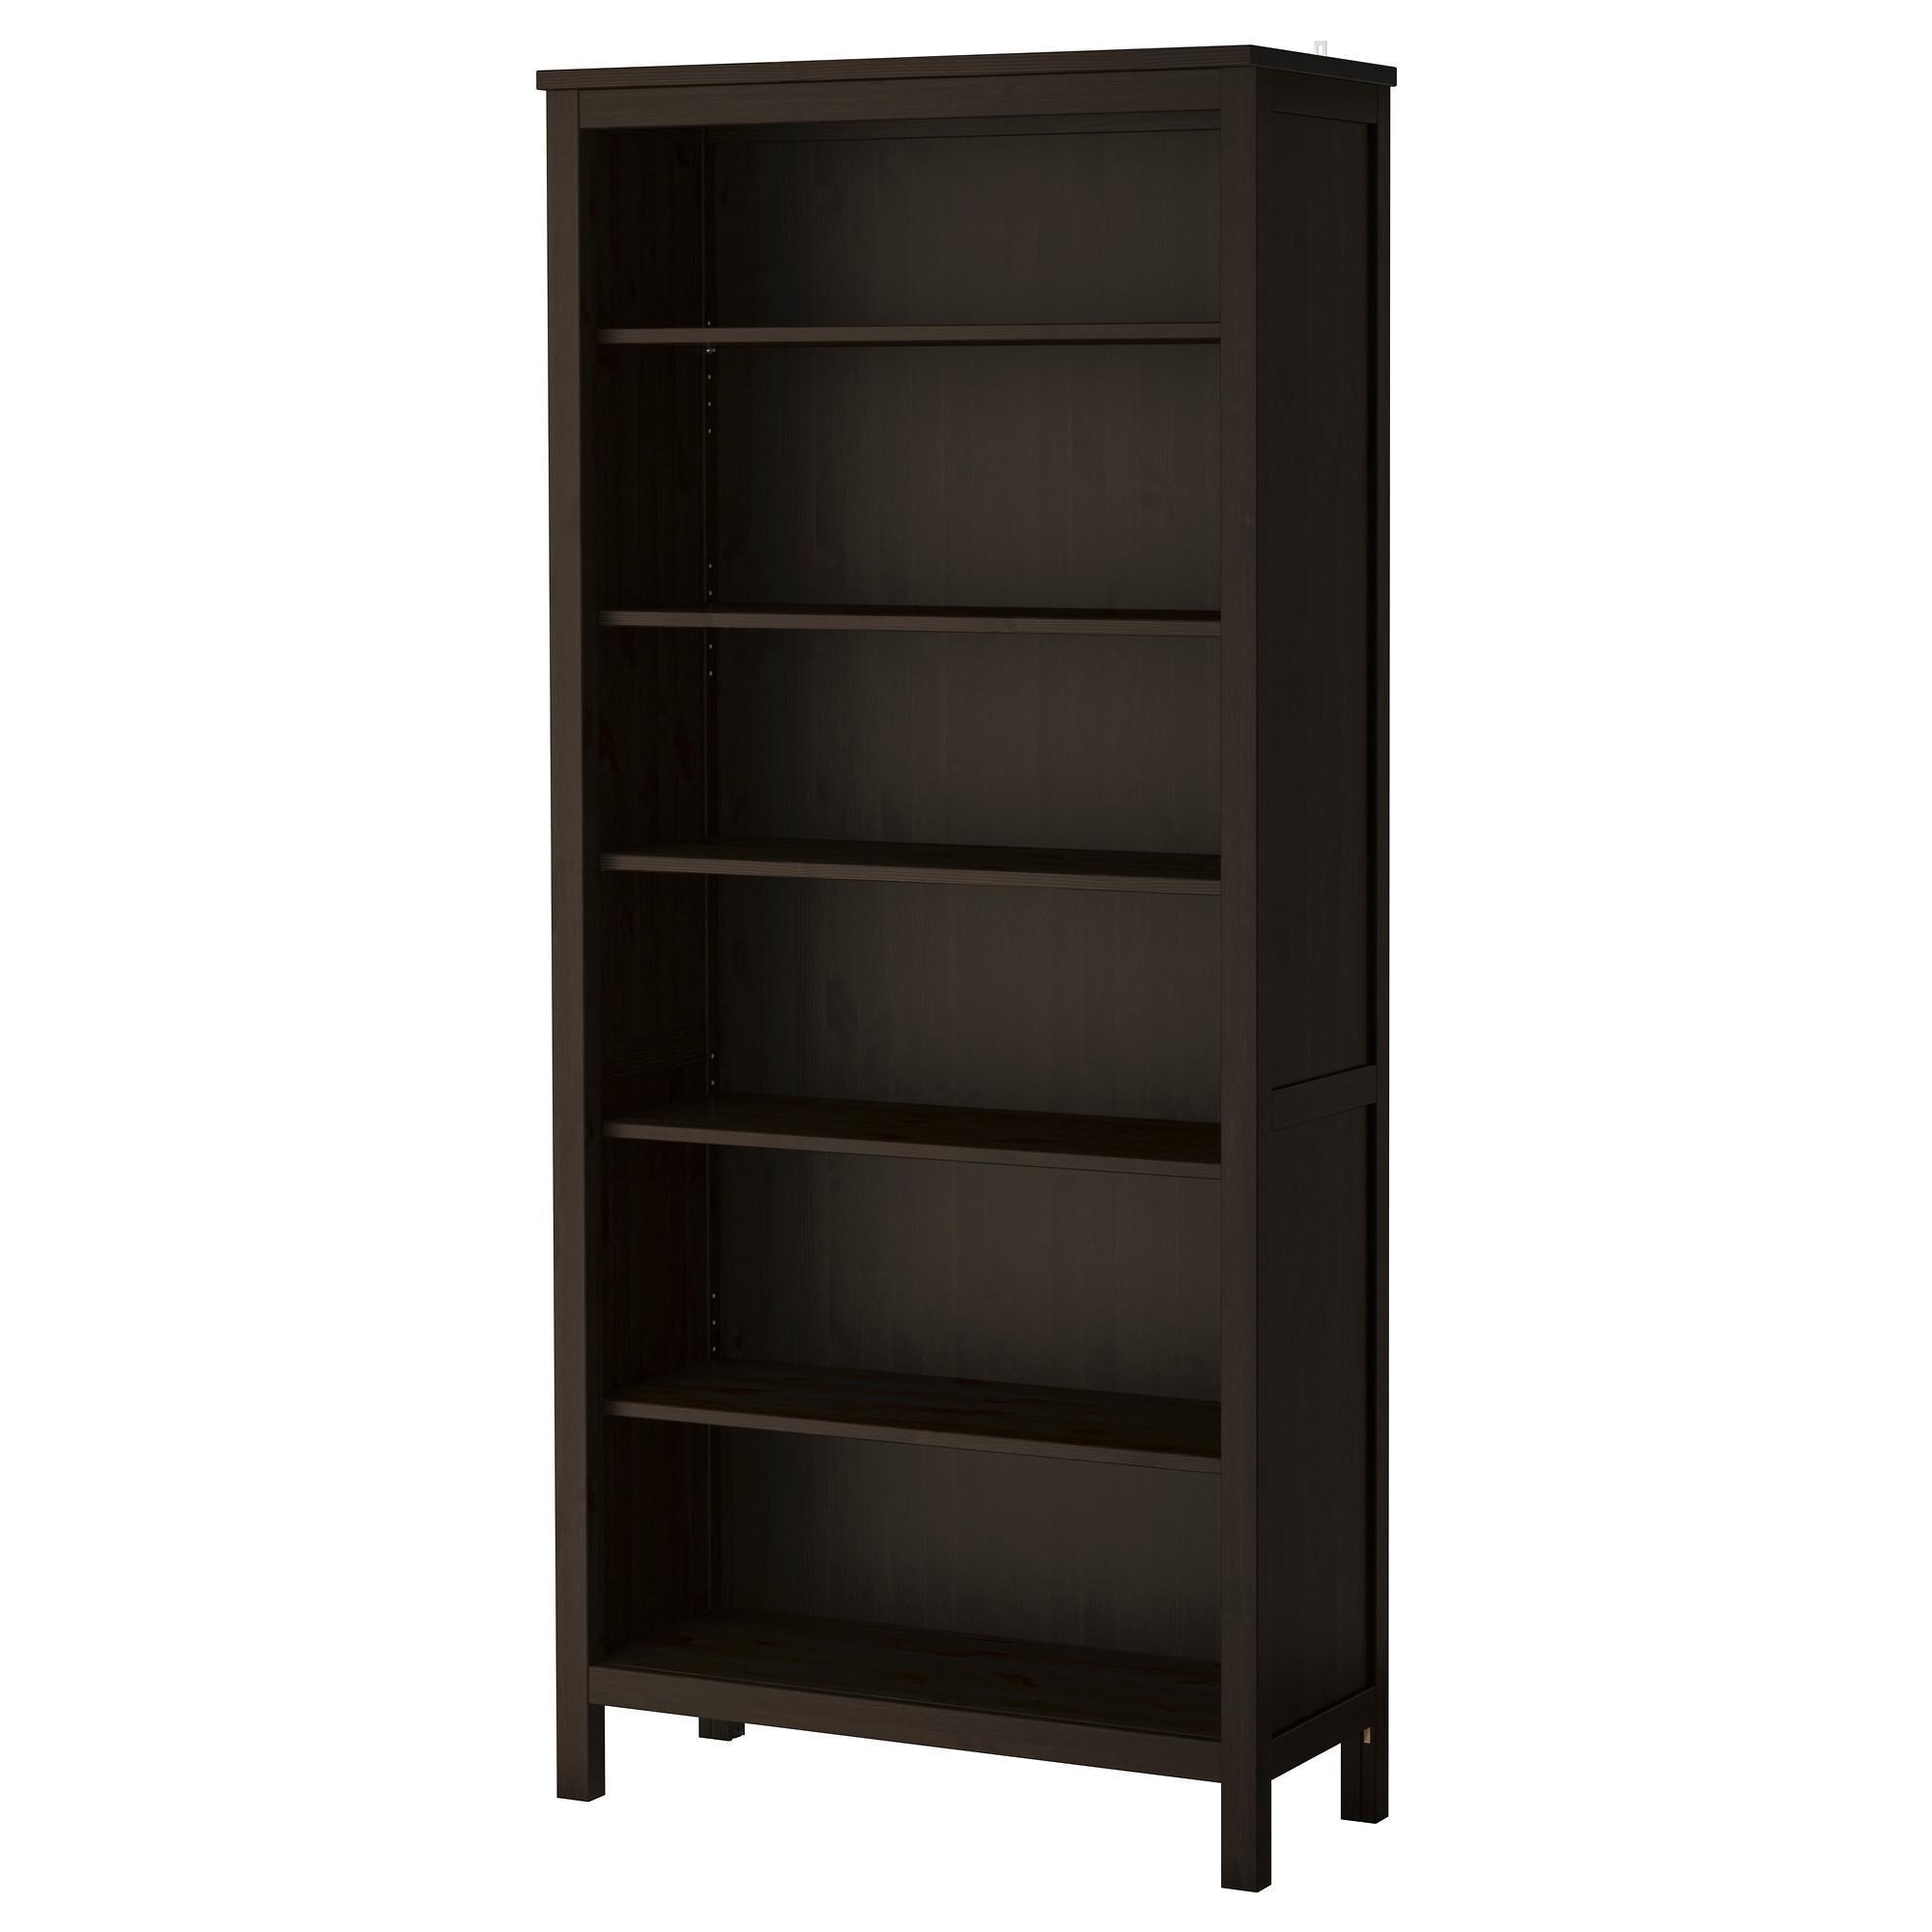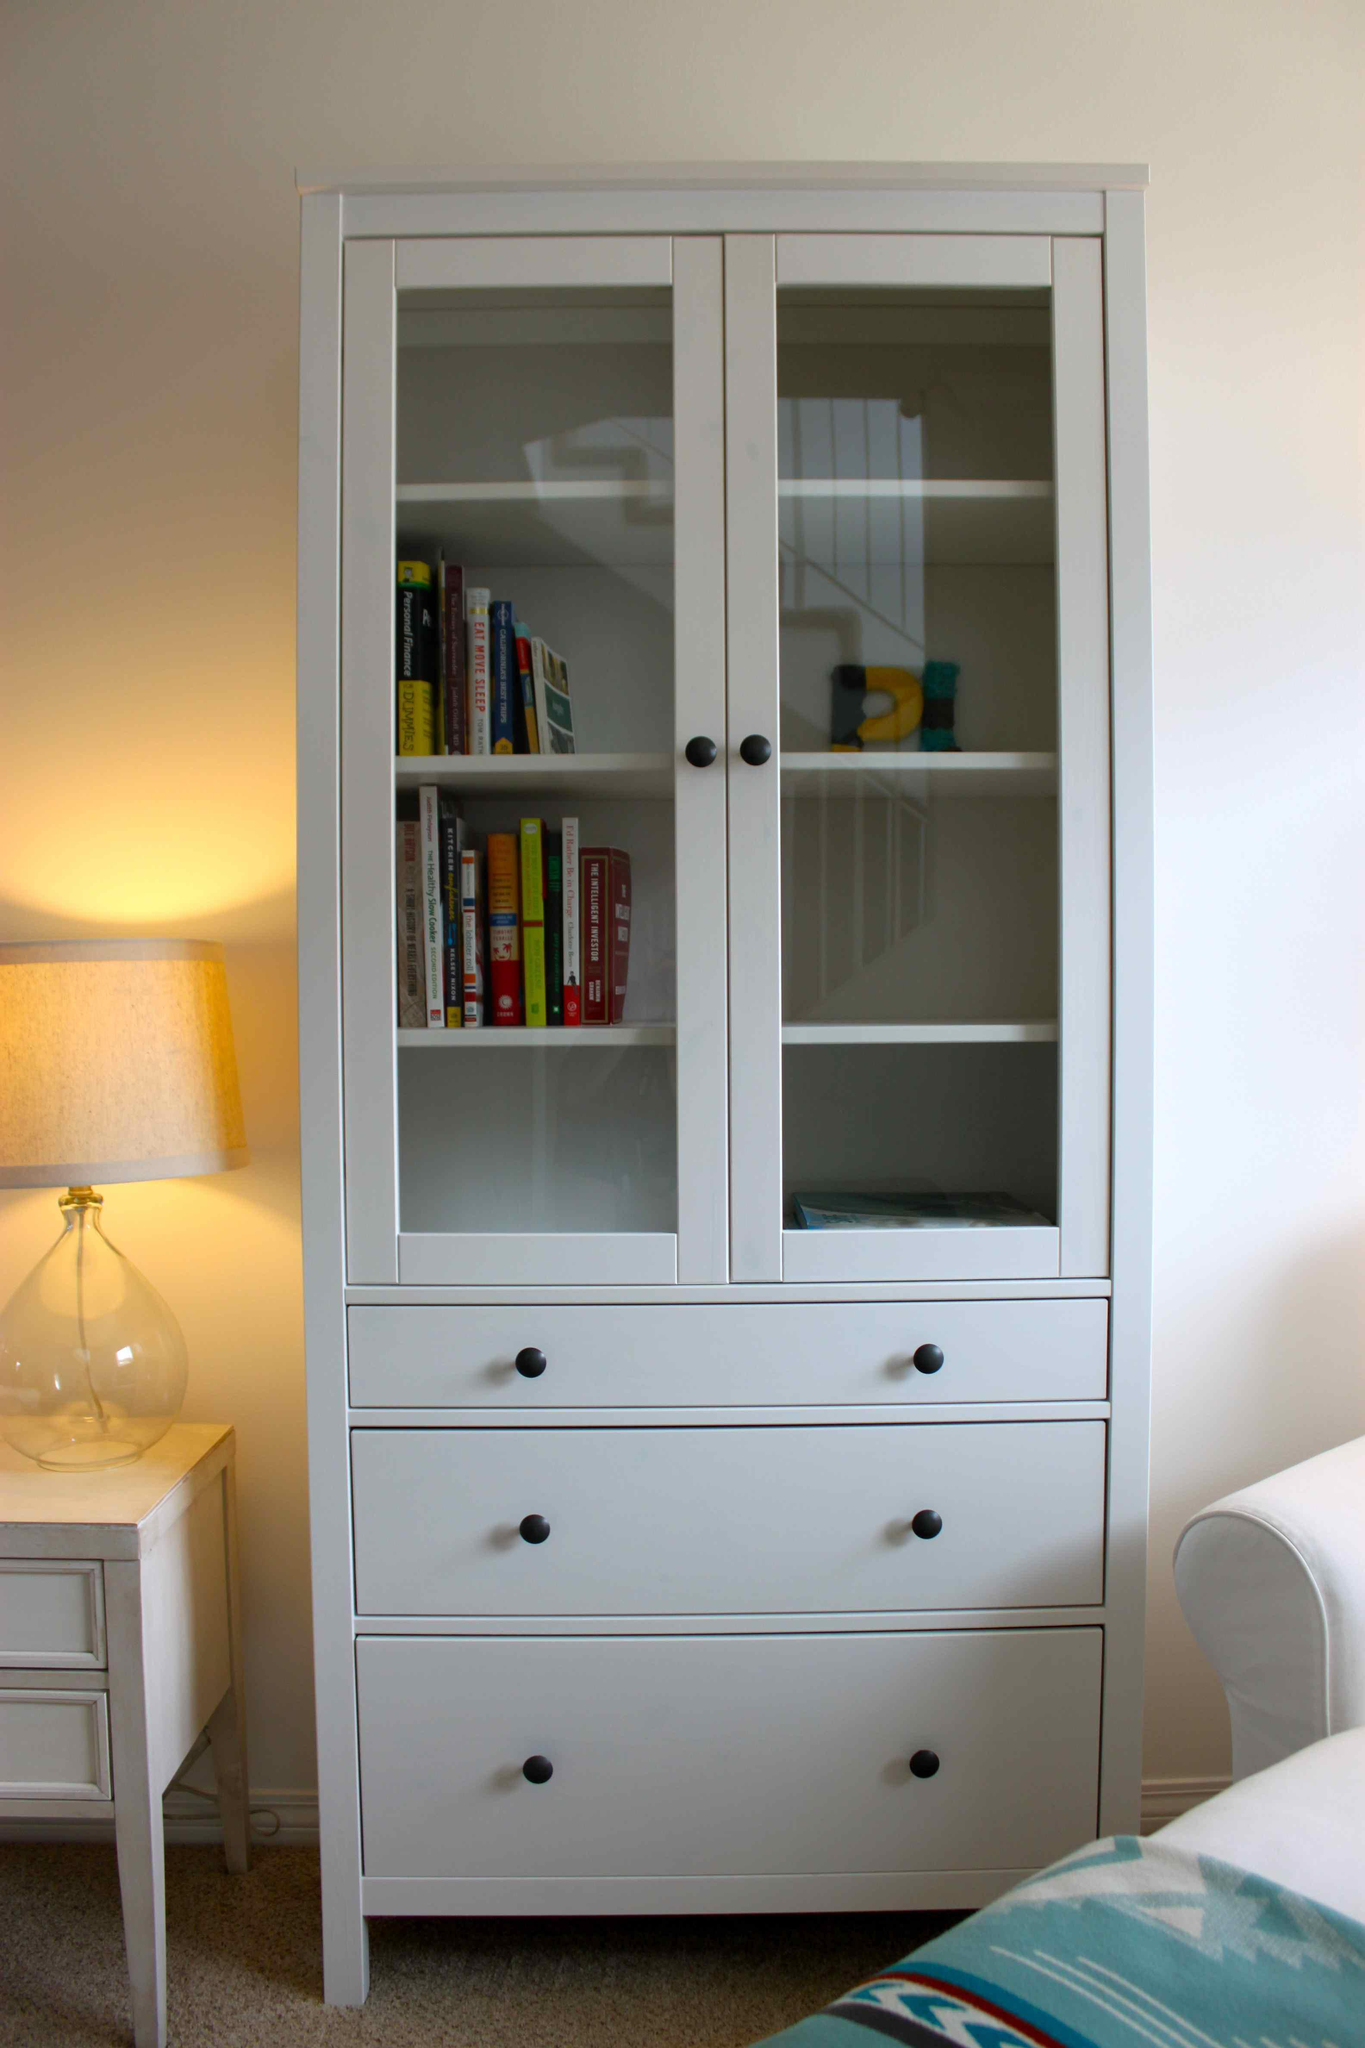The first image is the image on the left, the second image is the image on the right. Given the left and right images, does the statement "In one image, a tall plain boxy bookshelf is a dark walnut color, stands on short legs, and has six shelves, all of them empty." hold true? Answer yes or no. Yes. The first image is the image on the left, the second image is the image on the right. Analyze the images presented: Is the assertion "The left image contains a dark brown bookshelf." valid? Answer yes or no. Yes. 